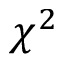<formula> <loc_0><loc_0><loc_500><loc_500>\chi ^ { 2 }</formula> 